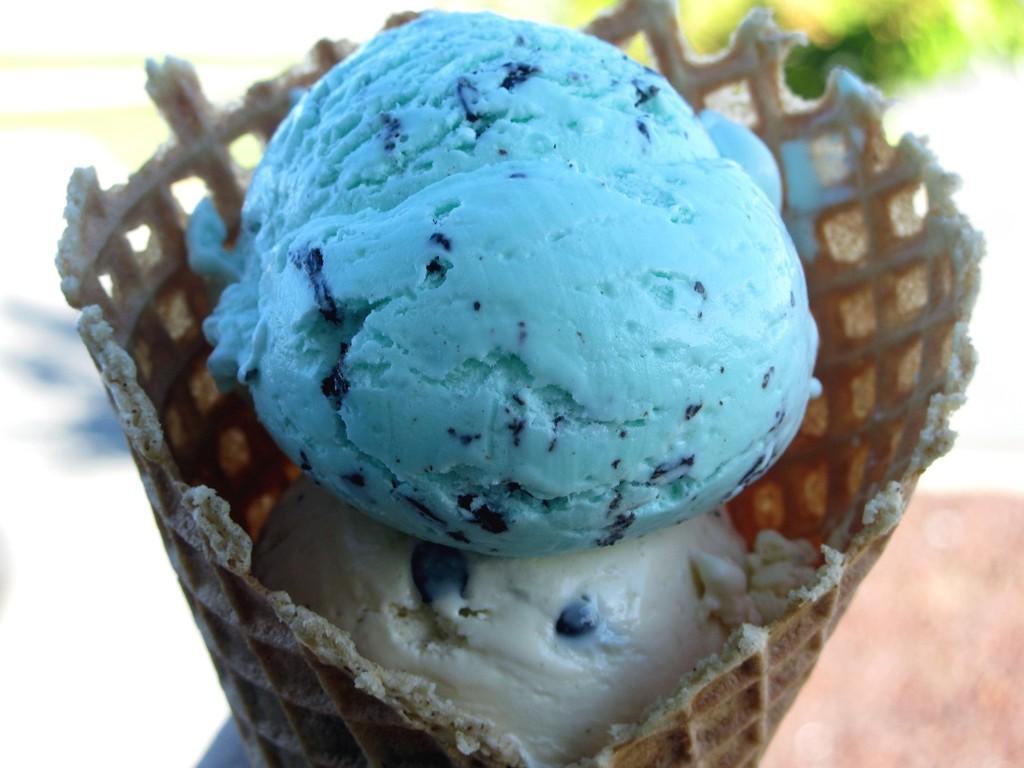Please provide a concise description of this image. In this image we can can see two scoops of ice cream in the cone, which are in white and blue color. 